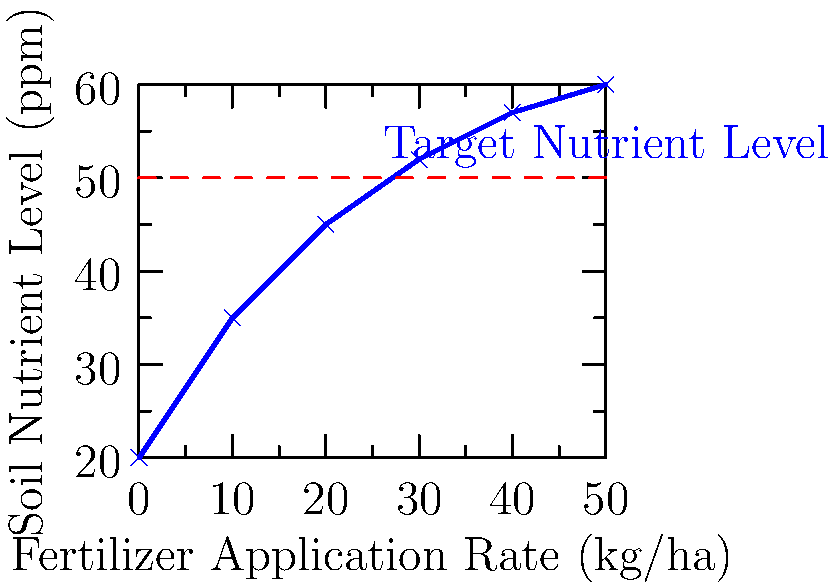Based on the soil nutrient graph provided, which shows the relationship between fertilizer application rate and soil nutrient level, determine the minimum fertilizer application rate (in kg/ha) needed to achieve a target soil nutrient level of 50 ppm. Round your answer to the nearest whole number. To solve this problem, we need to follow these steps:

1. Identify the target nutrient level on the y-axis (50 ppm).
2. Trace a horizontal line from this point to intersect with the curve.
3. From the intersection point, draw a vertical line down to the x-axis.
4. Read the corresponding fertilizer application rate on the x-axis.

Looking at the graph:

1. The target nutrient level of 50 ppm is marked with a dashed red line.
2. This line intersects the blue curve between the points (20, 45) and (30, 52).
3. The intersection appears to be closer to the 30 kg/ha mark on the x-axis.

To be more precise:

4. We can estimate the intersection point using linear interpolation between these two known points.

Let's calculate:

$$ \frac{50 - 45}{52 - 45} = \frac{x - 20}{30 - 20} $$

$$ \frac{5}{7} = \frac{x - 20}{10} $$

$$ 5 \cdot 10 = 7(x - 20) $$

$$ 50 = 7x - 140 $$

$$ 190 = 7x $$

$$ x = \frac{190}{7} \approx 27.14 $$

Rounding to the nearest whole number, we get 27 kg/ha.
Answer: 27 kg/ha 